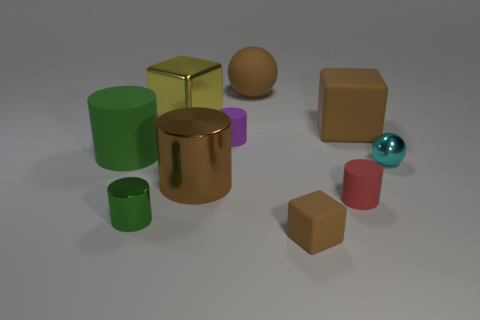How many other things are there of the same color as the small matte block?
Keep it short and to the point. 3. Is the number of matte cylinders behind the big brown metal object greater than the number of purple rubber spheres?
Offer a terse response. Yes. The block that is on the right side of the tiny matte object that is on the right side of the brown matte object in front of the small green shiny cylinder is what color?
Your answer should be compact. Brown. Do the cyan ball and the purple object have the same material?
Your response must be concise. No. Are there any green things of the same size as the cyan ball?
Your response must be concise. Yes. There is a brown ball that is the same size as the yellow block; what is it made of?
Offer a terse response. Rubber. Are there any small gray objects that have the same shape as the tiny red thing?
Make the answer very short. No. What is the material of the small object that is the same color as the big matte cylinder?
Ensure brevity in your answer.  Metal. There is a big brown thing that is behind the big brown rubber block; what is its shape?
Make the answer very short. Sphere. How many brown rubber balls are there?
Give a very brief answer. 1. 